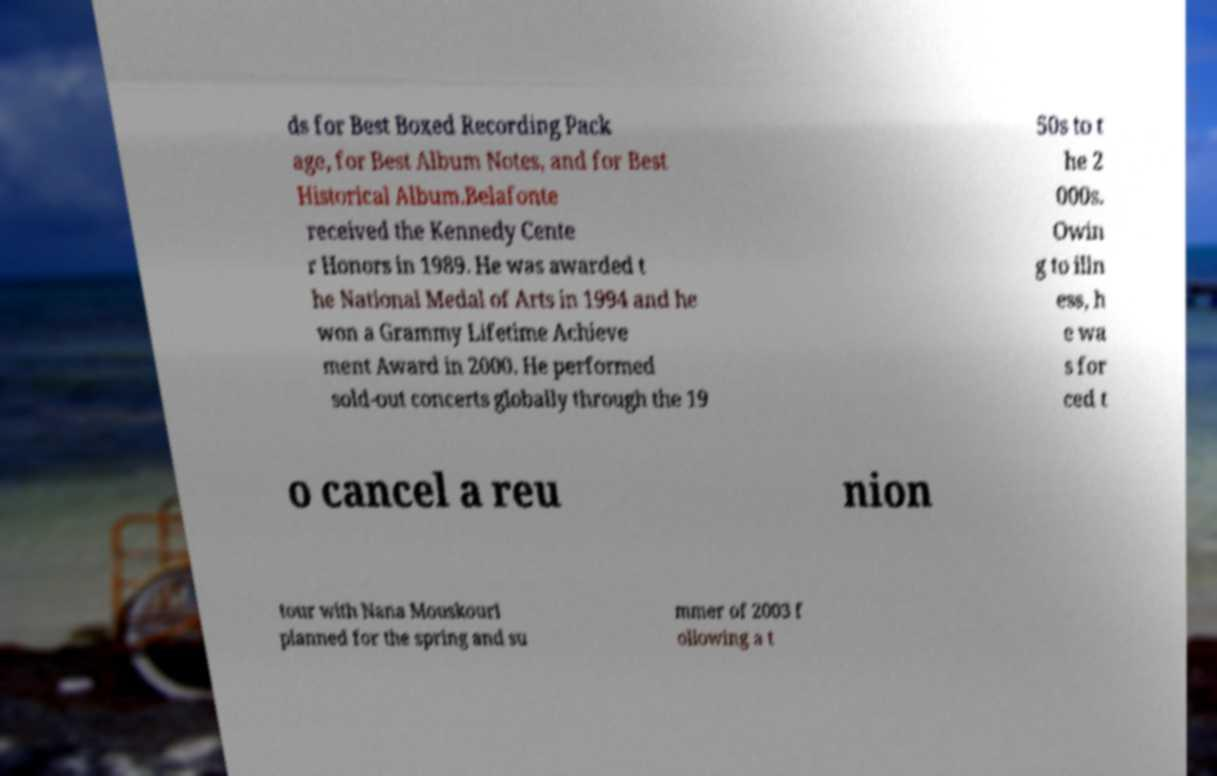Could you assist in decoding the text presented in this image and type it out clearly? ds for Best Boxed Recording Pack age, for Best Album Notes, and for Best Historical Album.Belafonte received the Kennedy Cente r Honors in 1989. He was awarded t he National Medal of Arts in 1994 and he won a Grammy Lifetime Achieve ment Award in 2000. He performed sold-out concerts globally through the 19 50s to t he 2 000s. Owin g to illn ess, h e wa s for ced t o cancel a reu nion tour with Nana Mouskouri planned for the spring and su mmer of 2003 f ollowing a t 